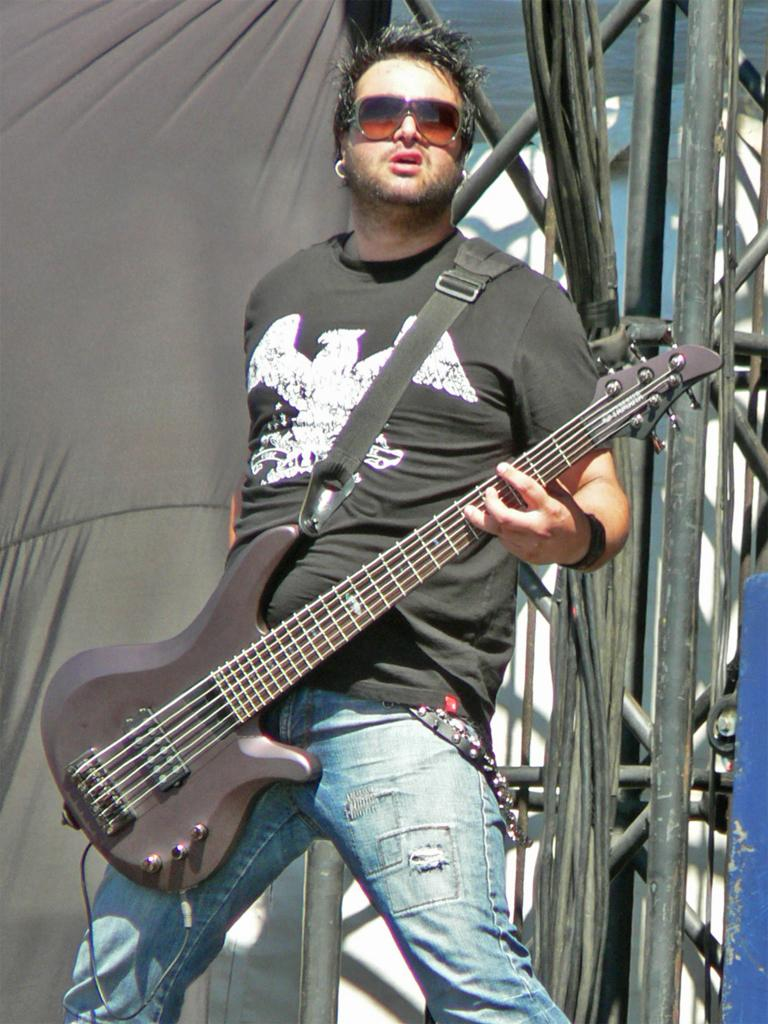What is the man in the image wearing? The man is wearing goggles. What is the man holding in the image? The man is holding a guitar. What is the man's posture in the image? The man is standing. What can be seen in the background of the image? There is a pole, a curtain, and wires in the background of the image. What grade does the man receive for his performance with the dolls and comb in the image? There are no dolls or comb present in the image, and therefore no performance or grade can be assessed. 